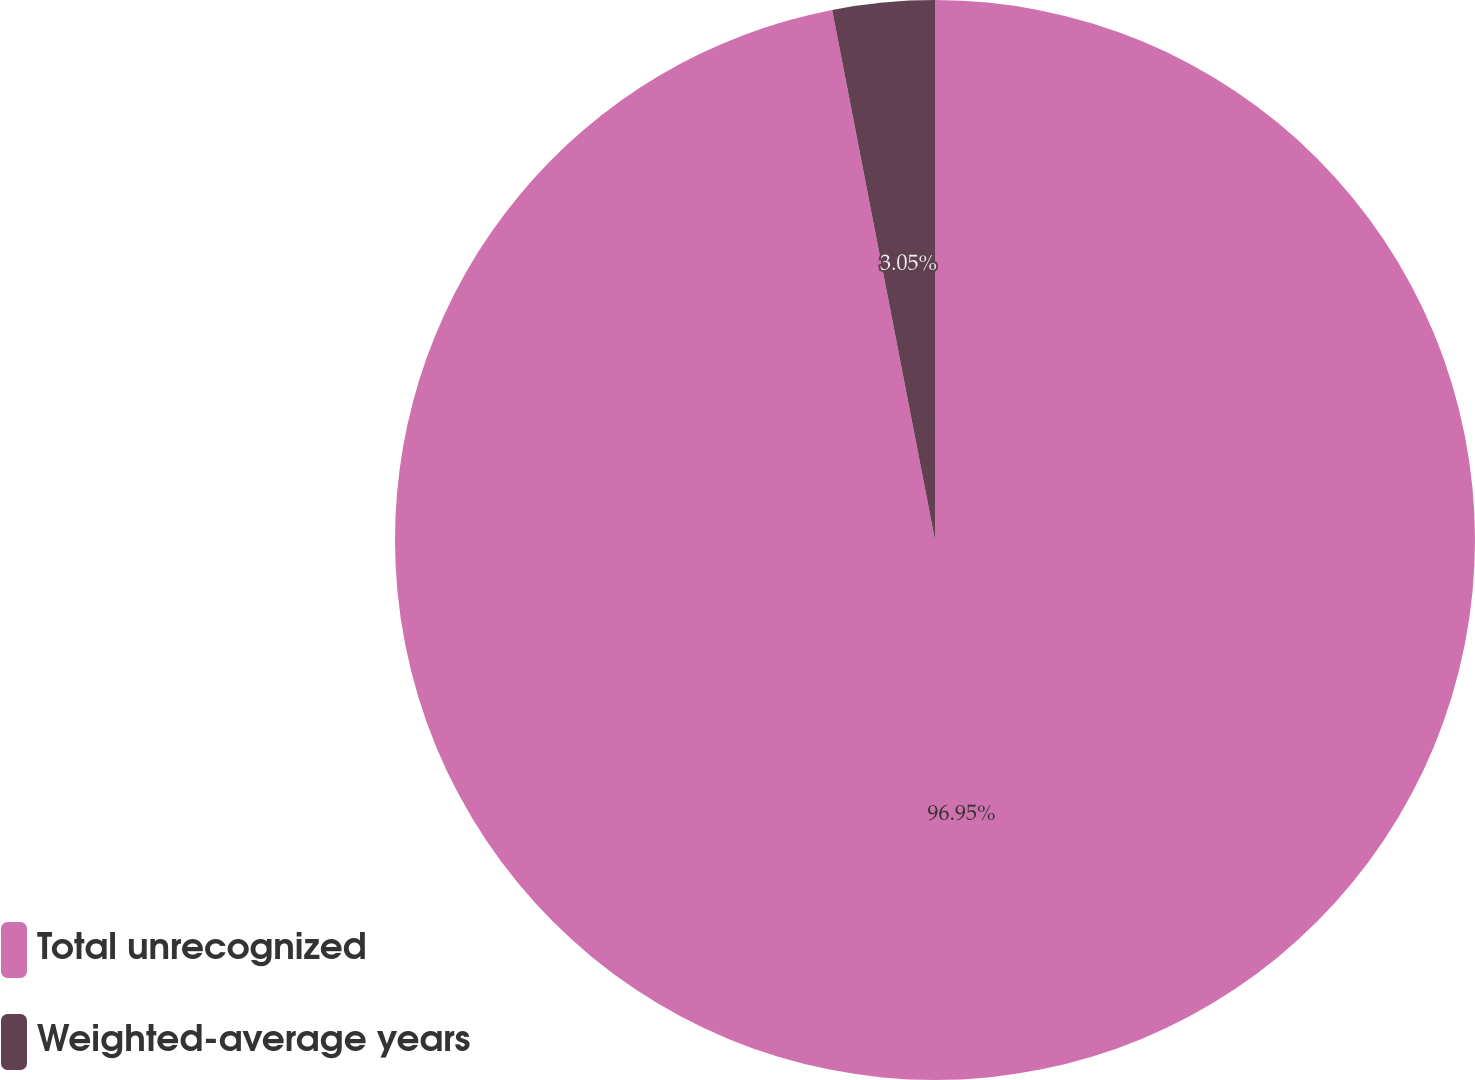Convert chart. <chart><loc_0><loc_0><loc_500><loc_500><pie_chart><fcel>Total unrecognized<fcel>Weighted-average years<nl><fcel>96.95%<fcel>3.05%<nl></chart> 